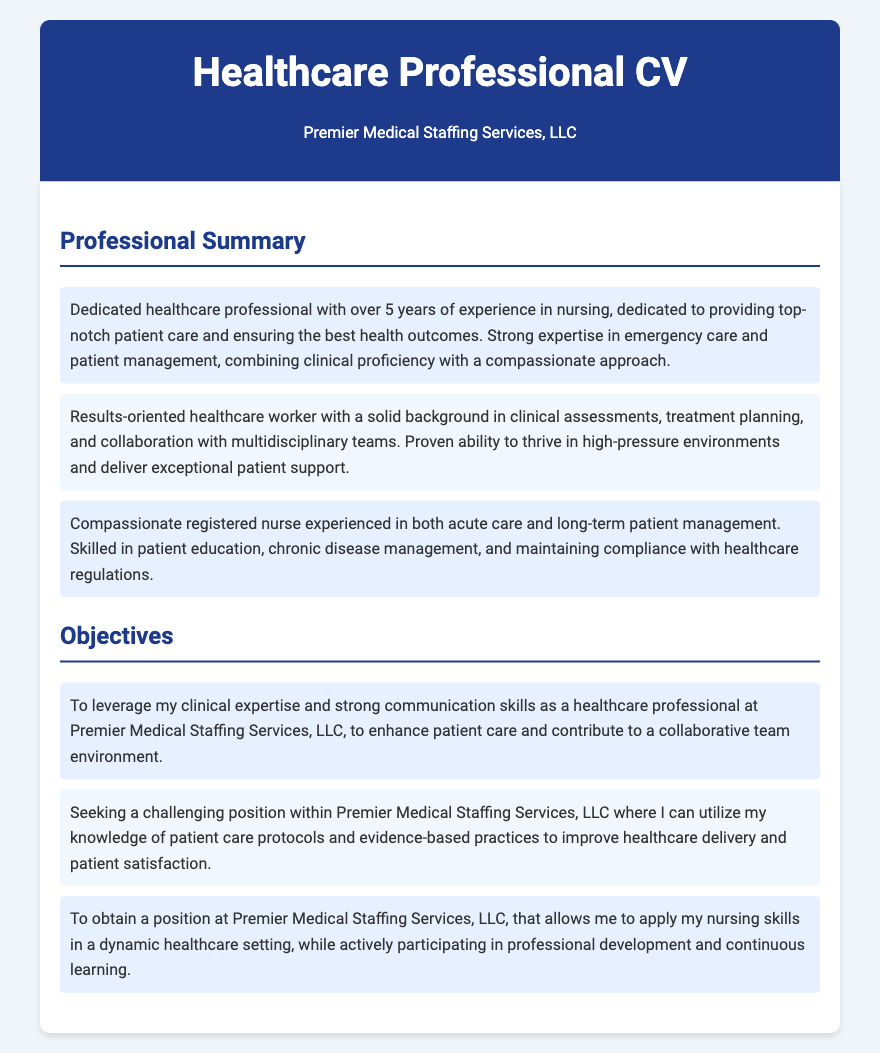what is the total years of experience mentioned in the Professional Summary? The document states "over 5 years of experience in nursing."
Answer: over 5 years what is the main focus of the professional summary? The summary highlights dedication to patient care and ensuring health outcomes through expertise in emergency care and patient management.
Answer: patient care and health outcomes what are the two environments mentioned for patient management experience? The summary lists "acute care and long-term patient management" as the environments of experience.
Answer: acute care and long-term patient management what is the objective related to professional development? One of the objectives states the desire to "actively participate in professional development and continuous learning."
Answer: professional development and continuous learning how many main points are listed under the Professional Summary? There are three main points provided in the Professional Summary section of the document.
Answer: three what type of position is sought in the objectives? The objectives seek a "challenging position within Premier Medical Staffing Services, LLC."
Answer: challenging position what skill is emphasized in the objectives for contributing to patient care? The objectives emphasize "clinical expertise and strong communication skills" as important for enhancing patient care.
Answer: clinical expertise and strong communication skills what color is the header background? The header background color is specified in the document as "dark blue."
Answer: dark blue 